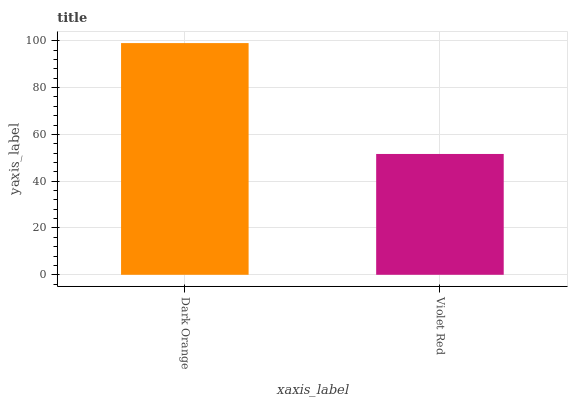Is Violet Red the minimum?
Answer yes or no. Yes. Is Dark Orange the maximum?
Answer yes or no. Yes. Is Violet Red the maximum?
Answer yes or no. No. Is Dark Orange greater than Violet Red?
Answer yes or no. Yes. Is Violet Red less than Dark Orange?
Answer yes or no. Yes. Is Violet Red greater than Dark Orange?
Answer yes or no. No. Is Dark Orange less than Violet Red?
Answer yes or no. No. Is Dark Orange the high median?
Answer yes or no. Yes. Is Violet Red the low median?
Answer yes or no. Yes. Is Violet Red the high median?
Answer yes or no. No. Is Dark Orange the low median?
Answer yes or no. No. 